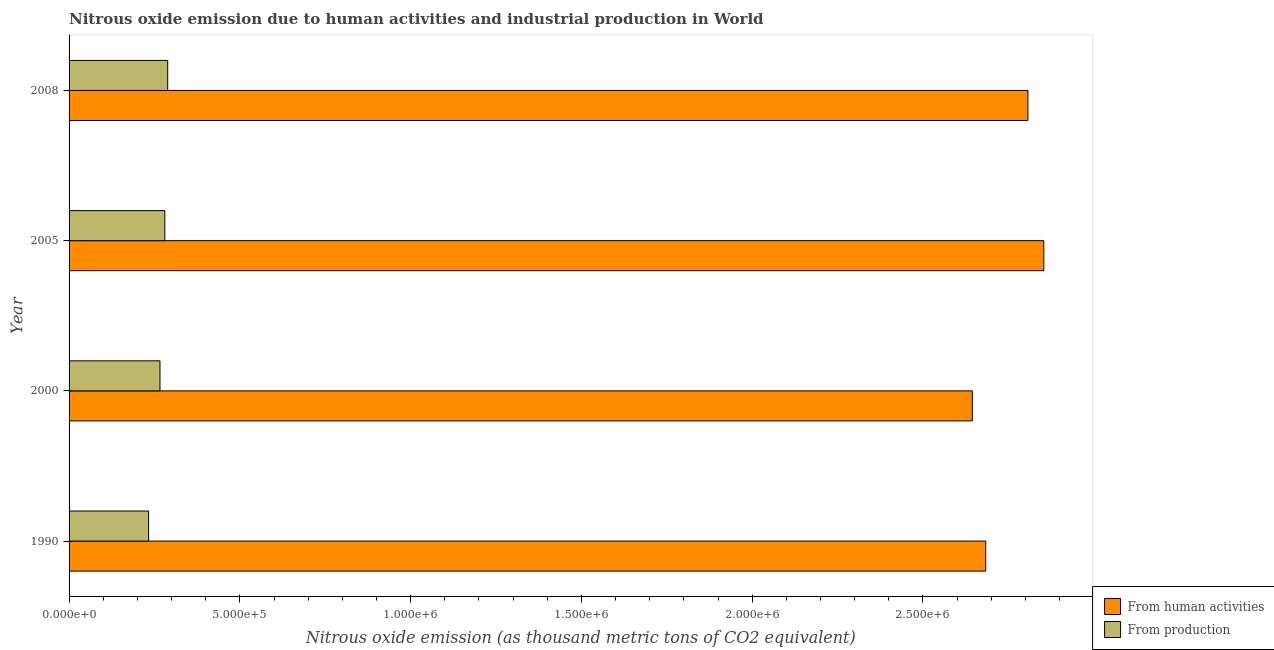Are the number of bars per tick equal to the number of legend labels?
Give a very brief answer. Yes. Are the number of bars on each tick of the Y-axis equal?
Keep it short and to the point. Yes. What is the amount of emissions from human activities in 2005?
Keep it short and to the point. 2.85e+06. Across all years, what is the maximum amount of emissions from human activities?
Give a very brief answer. 2.85e+06. Across all years, what is the minimum amount of emissions from human activities?
Your answer should be compact. 2.64e+06. In which year was the amount of emissions generated from industries maximum?
Provide a succinct answer. 2008. What is the total amount of emissions from human activities in the graph?
Make the answer very short. 1.10e+07. What is the difference between the amount of emissions generated from industries in 1990 and that in 2000?
Your response must be concise. -3.32e+04. What is the difference between the amount of emissions from human activities in 2005 and the amount of emissions generated from industries in 1990?
Your answer should be very brief. 2.62e+06. What is the average amount of emissions from human activities per year?
Your answer should be very brief. 2.75e+06. In the year 2005, what is the difference between the amount of emissions generated from industries and amount of emissions from human activities?
Your response must be concise. -2.57e+06. In how many years, is the amount of emissions generated from industries greater than 800000 thousand metric tons?
Provide a short and direct response. 0. What is the ratio of the amount of emissions generated from industries in 1990 to that in 2008?
Provide a short and direct response. 0.81. What is the difference between the highest and the second highest amount of emissions from human activities?
Provide a short and direct response. 4.66e+04. What is the difference between the highest and the lowest amount of emissions from human activities?
Offer a very short reply. 2.09e+05. What does the 1st bar from the top in 2008 represents?
Your answer should be very brief. From production. What does the 2nd bar from the bottom in 2008 represents?
Give a very brief answer. From production. What is the difference between two consecutive major ticks on the X-axis?
Provide a succinct answer. 5.00e+05. Are the values on the major ticks of X-axis written in scientific E-notation?
Make the answer very short. Yes. Does the graph contain any zero values?
Offer a very short reply. No. Does the graph contain grids?
Your response must be concise. No. How many legend labels are there?
Give a very brief answer. 2. How are the legend labels stacked?
Ensure brevity in your answer.  Vertical. What is the title of the graph?
Provide a short and direct response. Nitrous oxide emission due to human activities and industrial production in World. What is the label or title of the X-axis?
Provide a short and direct response. Nitrous oxide emission (as thousand metric tons of CO2 equivalent). What is the label or title of the Y-axis?
Keep it short and to the point. Year. What is the Nitrous oxide emission (as thousand metric tons of CO2 equivalent) in From human activities in 1990?
Provide a short and direct response. 2.68e+06. What is the Nitrous oxide emission (as thousand metric tons of CO2 equivalent) in From production in 1990?
Provide a short and direct response. 2.33e+05. What is the Nitrous oxide emission (as thousand metric tons of CO2 equivalent) of From human activities in 2000?
Your answer should be very brief. 2.64e+06. What is the Nitrous oxide emission (as thousand metric tons of CO2 equivalent) in From production in 2000?
Provide a short and direct response. 2.66e+05. What is the Nitrous oxide emission (as thousand metric tons of CO2 equivalent) of From human activities in 2005?
Provide a short and direct response. 2.85e+06. What is the Nitrous oxide emission (as thousand metric tons of CO2 equivalent) in From production in 2005?
Provide a short and direct response. 2.80e+05. What is the Nitrous oxide emission (as thousand metric tons of CO2 equivalent) in From human activities in 2008?
Give a very brief answer. 2.81e+06. What is the Nitrous oxide emission (as thousand metric tons of CO2 equivalent) of From production in 2008?
Ensure brevity in your answer.  2.89e+05. Across all years, what is the maximum Nitrous oxide emission (as thousand metric tons of CO2 equivalent) in From human activities?
Your answer should be compact. 2.85e+06. Across all years, what is the maximum Nitrous oxide emission (as thousand metric tons of CO2 equivalent) of From production?
Provide a succinct answer. 2.89e+05. Across all years, what is the minimum Nitrous oxide emission (as thousand metric tons of CO2 equivalent) of From human activities?
Your answer should be compact. 2.64e+06. Across all years, what is the minimum Nitrous oxide emission (as thousand metric tons of CO2 equivalent) in From production?
Offer a very short reply. 2.33e+05. What is the total Nitrous oxide emission (as thousand metric tons of CO2 equivalent) in From human activities in the graph?
Offer a very short reply. 1.10e+07. What is the total Nitrous oxide emission (as thousand metric tons of CO2 equivalent) in From production in the graph?
Make the answer very short. 1.07e+06. What is the difference between the Nitrous oxide emission (as thousand metric tons of CO2 equivalent) of From human activities in 1990 and that in 2000?
Keep it short and to the point. 3.92e+04. What is the difference between the Nitrous oxide emission (as thousand metric tons of CO2 equivalent) in From production in 1990 and that in 2000?
Your response must be concise. -3.32e+04. What is the difference between the Nitrous oxide emission (as thousand metric tons of CO2 equivalent) in From human activities in 1990 and that in 2005?
Provide a succinct answer. -1.70e+05. What is the difference between the Nitrous oxide emission (as thousand metric tons of CO2 equivalent) of From production in 1990 and that in 2005?
Provide a succinct answer. -4.74e+04. What is the difference between the Nitrous oxide emission (as thousand metric tons of CO2 equivalent) of From human activities in 1990 and that in 2008?
Offer a very short reply. -1.24e+05. What is the difference between the Nitrous oxide emission (as thousand metric tons of CO2 equivalent) in From production in 1990 and that in 2008?
Ensure brevity in your answer.  -5.58e+04. What is the difference between the Nitrous oxide emission (as thousand metric tons of CO2 equivalent) in From human activities in 2000 and that in 2005?
Your response must be concise. -2.09e+05. What is the difference between the Nitrous oxide emission (as thousand metric tons of CO2 equivalent) of From production in 2000 and that in 2005?
Offer a very short reply. -1.42e+04. What is the difference between the Nitrous oxide emission (as thousand metric tons of CO2 equivalent) of From human activities in 2000 and that in 2008?
Your response must be concise. -1.63e+05. What is the difference between the Nitrous oxide emission (as thousand metric tons of CO2 equivalent) of From production in 2000 and that in 2008?
Your response must be concise. -2.25e+04. What is the difference between the Nitrous oxide emission (as thousand metric tons of CO2 equivalent) of From human activities in 2005 and that in 2008?
Ensure brevity in your answer.  4.66e+04. What is the difference between the Nitrous oxide emission (as thousand metric tons of CO2 equivalent) of From production in 2005 and that in 2008?
Give a very brief answer. -8372.6. What is the difference between the Nitrous oxide emission (as thousand metric tons of CO2 equivalent) of From human activities in 1990 and the Nitrous oxide emission (as thousand metric tons of CO2 equivalent) of From production in 2000?
Offer a very short reply. 2.42e+06. What is the difference between the Nitrous oxide emission (as thousand metric tons of CO2 equivalent) of From human activities in 1990 and the Nitrous oxide emission (as thousand metric tons of CO2 equivalent) of From production in 2005?
Your response must be concise. 2.40e+06. What is the difference between the Nitrous oxide emission (as thousand metric tons of CO2 equivalent) in From human activities in 1990 and the Nitrous oxide emission (as thousand metric tons of CO2 equivalent) in From production in 2008?
Your answer should be compact. 2.40e+06. What is the difference between the Nitrous oxide emission (as thousand metric tons of CO2 equivalent) of From human activities in 2000 and the Nitrous oxide emission (as thousand metric tons of CO2 equivalent) of From production in 2005?
Ensure brevity in your answer.  2.36e+06. What is the difference between the Nitrous oxide emission (as thousand metric tons of CO2 equivalent) in From human activities in 2000 and the Nitrous oxide emission (as thousand metric tons of CO2 equivalent) in From production in 2008?
Provide a short and direct response. 2.36e+06. What is the difference between the Nitrous oxide emission (as thousand metric tons of CO2 equivalent) in From human activities in 2005 and the Nitrous oxide emission (as thousand metric tons of CO2 equivalent) in From production in 2008?
Provide a short and direct response. 2.57e+06. What is the average Nitrous oxide emission (as thousand metric tons of CO2 equivalent) in From human activities per year?
Your answer should be very brief. 2.75e+06. What is the average Nitrous oxide emission (as thousand metric tons of CO2 equivalent) of From production per year?
Your answer should be very brief. 2.67e+05. In the year 1990, what is the difference between the Nitrous oxide emission (as thousand metric tons of CO2 equivalent) in From human activities and Nitrous oxide emission (as thousand metric tons of CO2 equivalent) in From production?
Offer a very short reply. 2.45e+06. In the year 2000, what is the difference between the Nitrous oxide emission (as thousand metric tons of CO2 equivalent) of From human activities and Nitrous oxide emission (as thousand metric tons of CO2 equivalent) of From production?
Provide a short and direct response. 2.38e+06. In the year 2005, what is the difference between the Nitrous oxide emission (as thousand metric tons of CO2 equivalent) in From human activities and Nitrous oxide emission (as thousand metric tons of CO2 equivalent) in From production?
Keep it short and to the point. 2.57e+06. In the year 2008, what is the difference between the Nitrous oxide emission (as thousand metric tons of CO2 equivalent) in From human activities and Nitrous oxide emission (as thousand metric tons of CO2 equivalent) in From production?
Keep it short and to the point. 2.52e+06. What is the ratio of the Nitrous oxide emission (as thousand metric tons of CO2 equivalent) in From human activities in 1990 to that in 2000?
Your answer should be very brief. 1.01. What is the ratio of the Nitrous oxide emission (as thousand metric tons of CO2 equivalent) of From production in 1990 to that in 2000?
Provide a short and direct response. 0.88. What is the ratio of the Nitrous oxide emission (as thousand metric tons of CO2 equivalent) in From human activities in 1990 to that in 2005?
Keep it short and to the point. 0.94. What is the ratio of the Nitrous oxide emission (as thousand metric tons of CO2 equivalent) of From production in 1990 to that in 2005?
Provide a succinct answer. 0.83. What is the ratio of the Nitrous oxide emission (as thousand metric tons of CO2 equivalent) in From human activities in 1990 to that in 2008?
Your response must be concise. 0.96. What is the ratio of the Nitrous oxide emission (as thousand metric tons of CO2 equivalent) of From production in 1990 to that in 2008?
Offer a very short reply. 0.81. What is the ratio of the Nitrous oxide emission (as thousand metric tons of CO2 equivalent) of From human activities in 2000 to that in 2005?
Provide a short and direct response. 0.93. What is the ratio of the Nitrous oxide emission (as thousand metric tons of CO2 equivalent) in From production in 2000 to that in 2005?
Provide a short and direct response. 0.95. What is the ratio of the Nitrous oxide emission (as thousand metric tons of CO2 equivalent) in From human activities in 2000 to that in 2008?
Keep it short and to the point. 0.94. What is the ratio of the Nitrous oxide emission (as thousand metric tons of CO2 equivalent) in From production in 2000 to that in 2008?
Offer a terse response. 0.92. What is the ratio of the Nitrous oxide emission (as thousand metric tons of CO2 equivalent) in From human activities in 2005 to that in 2008?
Offer a terse response. 1.02. What is the ratio of the Nitrous oxide emission (as thousand metric tons of CO2 equivalent) in From production in 2005 to that in 2008?
Keep it short and to the point. 0.97. What is the difference between the highest and the second highest Nitrous oxide emission (as thousand metric tons of CO2 equivalent) of From human activities?
Provide a succinct answer. 4.66e+04. What is the difference between the highest and the second highest Nitrous oxide emission (as thousand metric tons of CO2 equivalent) of From production?
Offer a very short reply. 8372.6. What is the difference between the highest and the lowest Nitrous oxide emission (as thousand metric tons of CO2 equivalent) in From human activities?
Make the answer very short. 2.09e+05. What is the difference between the highest and the lowest Nitrous oxide emission (as thousand metric tons of CO2 equivalent) in From production?
Your answer should be compact. 5.58e+04. 